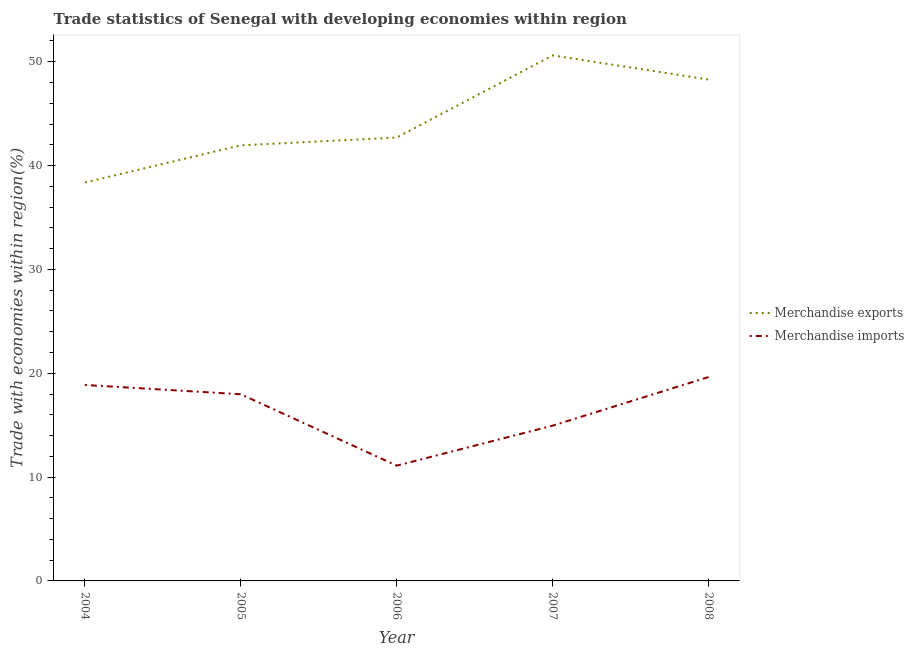What is the merchandise exports in 2006?
Your answer should be very brief. 42.7. Across all years, what is the maximum merchandise imports?
Your answer should be very brief. 19.64. Across all years, what is the minimum merchandise imports?
Provide a short and direct response. 11.1. In which year was the merchandise imports minimum?
Your answer should be very brief. 2006. What is the total merchandise imports in the graph?
Offer a terse response. 82.54. What is the difference between the merchandise imports in 2004 and that in 2005?
Make the answer very short. 0.89. What is the difference between the merchandise exports in 2007 and the merchandise imports in 2008?
Your response must be concise. 30.98. What is the average merchandise exports per year?
Your answer should be very brief. 44.38. In the year 2007, what is the difference between the merchandise exports and merchandise imports?
Provide a short and direct response. 35.66. What is the ratio of the merchandise exports in 2004 to that in 2007?
Keep it short and to the point. 0.76. Is the difference between the merchandise exports in 2004 and 2006 greater than the difference between the merchandise imports in 2004 and 2006?
Ensure brevity in your answer.  No. What is the difference between the highest and the second highest merchandise exports?
Your response must be concise. 2.33. What is the difference between the highest and the lowest merchandise exports?
Provide a short and direct response. 12.24. In how many years, is the merchandise exports greater than the average merchandise exports taken over all years?
Give a very brief answer. 2. Does the merchandise imports monotonically increase over the years?
Provide a short and direct response. No. Is the merchandise exports strictly greater than the merchandise imports over the years?
Your answer should be compact. Yes. How many lines are there?
Offer a very short reply. 2. How many years are there in the graph?
Offer a terse response. 5. Are the values on the major ticks of Y-axis written in scientific E-notation?
Offer a very short reply. No. Does the graph contain grids?
Your answer should be compact. No. Where does the legend appear in the graph?
Provide a short and direct response. Center right. What is the title of the graph?
Provide a short and direct response. Trade statistics of Senegal with developing economies within region. Does "From production" appear as one of the legend labels in the graph?
Ensure brevity in your answer.  No. What is the label or title of the X-axis?
Offer a very short reply. Year. What is the label or title of the Y-axis?
Offer a terse response. Trade with economies within region(%). What is the Trade with economies within region(%) of Merchandise exports in 2004?
Provide a succinct answer. 38.37. What is the Trade with economies within region(%) of Merchandise imports in 2004?
Keep it short and to the point. 18.87. What is the Trade with economies within region(%) in Merchandise exports in 2005?
Make the answer very short. 41.95. What is the Trade with economies within region(%) in Merchandise imports in 2005?
Ensure brevity in your answer.  17.98. What is the Trade with economies within region(%) in Merchandise exports in 2006?
Your answer should be compact. 42.7. What is the Trade with economies within region(%) in Merchandise imports in 2006?
Make the answer very short. 11.1. What is the Trade with economies within region(%) of Merchandise exports in 2007?
Make the answer very short. 50.61. What is the Trade with economies within region(%) of Merchandise imports in 2007?
Give a very brief answer. 14.95. What is the Trade with economies within region(%) of Merchandise exports in 2008?
Offer a terse response. 48.29. What is the Trade with economies within region(%) in Merchandise imports in 2008?
Make the answer very short. 19.64. Across all years, what is the maximum Trade with economies within region(%) of Merchandise exports?
Your answer should be very brief. 50.61. Across all years, what is the maximum Trade with economies within region(%) of Merchandise imports?
Provide a succinct answer. 19.64. Across all years, what is the minimum Trade with economies within region(%) of Merchandise exports?
Offer a very short reply. 38.37. Across all years, what is the minimum Trade with economies within region(%) of Merchandise imports?
Provide a succinct answer. 11.1. What is the total Trade with economies within region(%) in Merchandise exports in the graph?
Make the answer very short. 221.92. What is the total Trade with economies within region(%) in Merchandise imports in the graph?
Provide a short and direct response. 82.54. What is the difference between the Trade with economies within region(%) of Merchandise exports in 2004 and that in 2005?
Ensure brevity in your answer.  -3.58. What is the difference between the Trade with economies within region(%) of Merchandise imports in 2004 and that in 2005?
Offer a very short reply. 0.89. What is the difference between the Trade with economies within region(%) in Merchandise exports in 2004 and that in 2006?
Provide a succinct answer. -4.33. What is the difference between the Trade with economies within region(%) in Merchandise imports in 2004 and that in 2006?
Provide a short and direct response. 7.77. What is the difference between the Trade with economies within region(%) in Merchandise exports in 2004 and that in 2007?
Provide a succinct answer. -12.24. What is the difference between the Trade with economies within region(%) of Merchandise imports in 2004 and that in 2007?
Keep it short and to the point. 3.92. What is the difference between the Trade with economies within region(%) of Merchandise exports in 2004 and that in 2008?
Provide a short and direct response. -9.91. What is the difference between the Trade with economies within region(%) of Merchandise imports in 2004 and that in 2008?
Keep it short and to the point. -0.76. What is the difference between the Trade with economies within region(%) of Merchandise exports in 2005 and that in 2006?
Offer a very short reply. -0.75. What is the difference between the Trade with economies within region(%) in Merchandise imports in 2005 and that in 2006?
Provide a short and direct response. 6.88. What is the difference between the Trade with economies within region(%) in Merchandise exports in 2005 and that in 2007?
Provide a succinct answer. -8.66. What is the difference between the Trade with economies within region(%) of Merchandise imports in 2005 and that in 2007?
Provide a short and direct response. 3.02. What is the difference between the Trade with economies within region(%) in Merchandise exports in 2005 and that in 2008?
Keep it short and to the point. -6.34. What is the difference between the Trade with economies within region(%) of Merchandise imports in 2005 and that in 2008?
Offer a terse response. -1.66. What is the difference between the Trade with economies within region(%) of Merchandise exports in 2006 and that in 2007?
Offer a terse response. -7.91. What is the difference between the Trade with economies within region(%) in Merchandise imports in 2006 and that in 2007?
Ensure brevity in your answer.  -3.85. What is the difference between the Trade with economies within region(%) in Merchandise exports in 2006 and that in 2008?
Your response must be concise. -5.58. What is the difference between the Trade with economies within region(%) of Merchandise imports in 2006 and that in 2008?
Offer a terse response. -8.53. What is the difference between the Trade with economies within region(%) of Merchandise exports in 2007 and that in 2008?
Ensure brevity in your answer.  2.33. What is the difference between the Trade with economies within region(%) in Merchandise imports in 2007 and that in 2008?
Offer a very short reply. -4.68. What is the difference between the Trade with economies within region(%) in Merchandise exports in 2004 and the Trade with economies within region(%) in Merchandise imports in 2005?
Keep it short and to the point. 20.39. What is the difference between the Trade with economies within region(%) of Merchandise exports in 2004 and the Trade with economies within region(%) of Merchandise imports in 2006?
Give a very brief answer. 27.27. What is the difference between the Trade with economies within region(%) of Merchandise exports in 2004 and the Trade with economies within region(%) of Merchandise imports in 2007?
Your answer should be compact. 23.42. What is the difference between the Trade with economies within region(%) in Merchandise exports in 2004 and the Trade with economies within region(%) in Merchandise imports in 2008?
Your answer should be very brief. 18.74. What is the difference between the Trade with economies within region(%) of Merchandise exports in 2005 and the Trade with economies within region(%) of Merchandise imports in 2006?
Keep it short and to the point. 30.85. What is the difference between the Trade with economies within region(%) of Merchandise exports in 2005 and the Trade with economies within region(%) of Merchandise imports in 2007?
Offer a terse response. 27. What is the difference between the Trade with economies within region(%) in Merchandise exports in 2005 and the Trade with economies within region(%) in Merchandise imports in 2008?
Provide a short and direct response. 22.31. What is the difference between the Trade with economies within region(%) in Merchandise exports in 2006 and the Trade with economies within region(%) in Merchandise imports in 2007?
Make the answer very short. 27.75. What is the difference between the Trade with economies within region(%) in Merchandise exports in 2006 and the Trade with economies within region(%) in Merchandise imports in 2008?
Ensure brevity in your answer.  23.07. What is the difference between the Trade with economies within region(%) of Merchandise exports in 2007 and the Trade with economies within region(%) of Merchandise imports in 2008?
Keep it short and to the point. 30.98. What is the average Trade with economies within region(%) of Merchandise exports per year?
Offer a very short reply. 44.38. What is the average Trade with economies within region(%) of Merchandise imports per year?
Keep it short and to the point. 16.51. In the year 2004, what is the difference between the Trade with economies within region(%) of Merchandise exports and Trade with economies within region(%) of Merchandise imports?
Make the answer very short. 19.5. In the year 2005, what is the difference between the Trade with economies within region(%) of Merchandise exports and Trade with economies within region(%) of Merchandise imports?
Offer a very short reply. 23.97. In the year 2006, what is the difference between the Trade with economies within region(%) in Merchandise exports and Trade with economies within region(%) in Merchandise imports?
Offer a terse response. 31.6. In the year 2007, what is the difference between the Trade with economies within region(%) in Merchandise exports and Trade with economies within region(%) in Merchandise imports?
Give a very brief answer. 35.66. In the year 2008, what is the difference between the Trade with economies within region(%) of Merchandise exports and Trade with economies within region(%) of Merchandise imports?
Keep it short and to the point. 28.65. What is the ratio of the Trade with economies within region(%) in Merchandise exports in 2004 to that in 2005?
Make the answer very short. 0.91. What is the ratio of the Trade with economies within region(%) of Merchandise imports in 2004 to that in 2005?
Provide a short and direct response. 1.05. What is the ratio of the Trade with economies within region(%) of Merchandise exports in 2004 to that in 2006?
Your answer should be very brief. 0.9. What is the ratio of the Trade with economies within region(%) in Merchandise imports in 2004 to that in 2006?
Keep it short and to the point. 1.7. What is the ratio of the Trade with economies within region(%) of Merchandise exports in 2004 to that in 2007?
Provide a short and direct response. 0.76. What is the ratio of the Trade with economies within region(%) of Merchandise imports in 2004 to that in 2007?
Provide a short and direct response. 1.26. What is the ratio of the Trade with economies within region(%) of Merchandise exports in 2004 to that in 2008?
Give a very brief answer. 0.79. What is the ratio of the Trade with economies within region(%) in Merchandise imports in 2004 to that in 2008?
Provide a short and direct response. 0.96. What is the ratio of the Trade with economies within region(%) of Merchandise exports in 2005 to that in 2006?
Ensure brevity in your answer.  0.98. What is the ratio of the Trade with economies within region(%) of Merchandise imports in 2005 to that in 2006?
Give a very brief answer. 1.62. What is the ratio of the Trade with economies within region(%) in Merchandise exports in 2005 to that in 2007?
Your answer should be very brief. 0.83. What is the ratio of the Trade with economies within region(%) in Merchandise imports in 2005 to that in 2007?
Your answer should be very brief. 1.2. What is the ratio of the Trade with economies within region(%) of Merchandise exports in 2005 to that in 2008?
Your answer should be very brief. 0.87. What is the ratio of the Trade with economies within region(%) in Merchandise imports in 2005 to that in 2008?
Ensure brevity in your answer.  0.92. What is the ratio of the Trade with economies within region(%) in Merchandise exports in 2006 to that in 2007?
Give a very brief answer. 0.84. What is the ratio of the Trade with economies within region(%) of Merchandise imports in 2006 to that in 2007?
Your response must be concise. 0.74. What is the ratio of the Trade with economies within region(%) in Merchandise exports in 2006 to that in 2008?
Offer a very short reply. 0.88. What is the ratio of the Trade with economies within region(%) in Merchandise imports in 2006 to that in 2008?
Keep it short and to the point. 0.57. What is the ratio of the Trade with economies within region(%) in Merchandise exports in 2007 to that in 2008?
Offer a very short reply. 1.05. What is the ratio of the Trade with economies within region(%) of Merchandise imports in 2007 to that in 2008?
Your response must be concise. 0.76. What is the difference between the highest and the second highest Trade with economies within region(%) in Merchandise exports?
Make the answer very short. 2.33. What is the difference between the highest and the second highest Trade with economies within region(%) of Merchandise imports?
Your answer should be very brief. 0.76. What is the difference between the highest and the lowest Trade with economies within region(%) in Merchandise exports?
Offer a terse response. 12.24. What is the difference between the highest and the lowest Trade with economies within region(%) in Merchandise imports?
Keep it short and to the point. 8.53. 